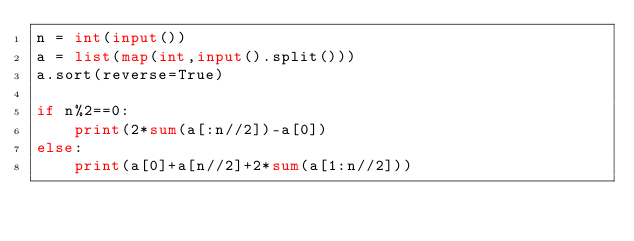Convert code to text. <code><loc_0><loc_0><loc_500><loc_500><_Python_>n = int(input())
a = list(map(int,input().split()))
a.sort(reverse=True)

if n%2==0:
    print(2*sum(a[:n//2])-a[0])
else:
    print(a[0]+a[n//2]+2*sum(a[1:n//2]))</code> 